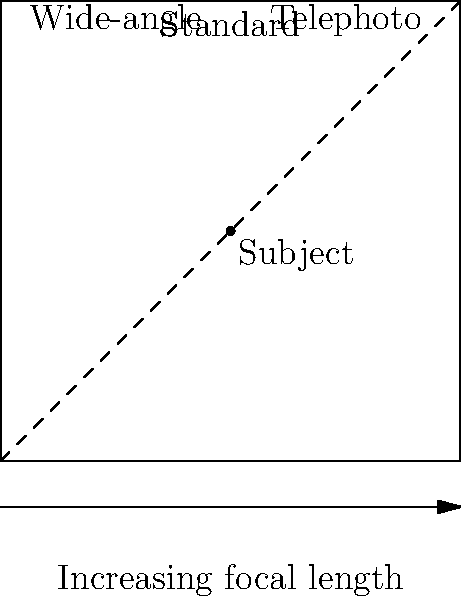As a seasoned photographer, you're preparing to capture a subject in the center of a square room. Given the diagram showing different lens options, which focal length would you choose to include the entire room in your composition while maintaining a natural perspective? To determine the optimal focal length for this scenario, let's consider the following steps:

1. Analyze the diagram:
   - The square represents the room
   - The subject is positioned in the center
   - Three lens options are presented: wide-angle, standard, and telephoto

2. Consider the characteristics of each lens type:
   - Wide-angle: Captures a broader field of view but may introduce distortion
   - Standard: Provides a natural perspective similar to human vision
   - Telephoto: Narrows the field of view and compresses perspective

3. Evaluate the requirements:
   - We need to include the entire room in the composition
   - We want to maintain a natural perspective

4. Make the decision:
   - A wide-angle lens would capture the entire room but might introduce unwanted distortion
   - A telephoto lens would not be able to capture the entire room from within
   - A standard lens (typically around 50mm on a full-frame camera) would provide a natural perspective and, depending on the room size, could potentially capture the entire space

5. Conclusion:
   The standard lens is the best choice as it offers a balance between field of view and natural perspective. It should allow you to capture the entire room without significant distortion, provided you can position yourself appropriately.
Answer: Standard lens 